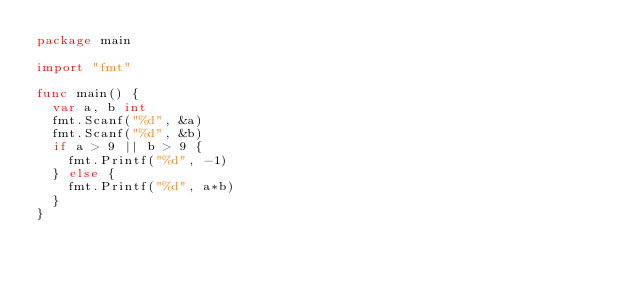<code> <loc_0><loc_0><loc_500><loc_500><_Go_>package main

import "fmt"

func main() {
	var a, b int
	fmt.Scanf("%d", &a)
	fmt.Scanf("%d", &b)
	if a > 9 || b > 9 {
		fmt.Printf("%d", -1)
	} else {
		fmt.Printf("%d", a*b)
	}
}</code> 